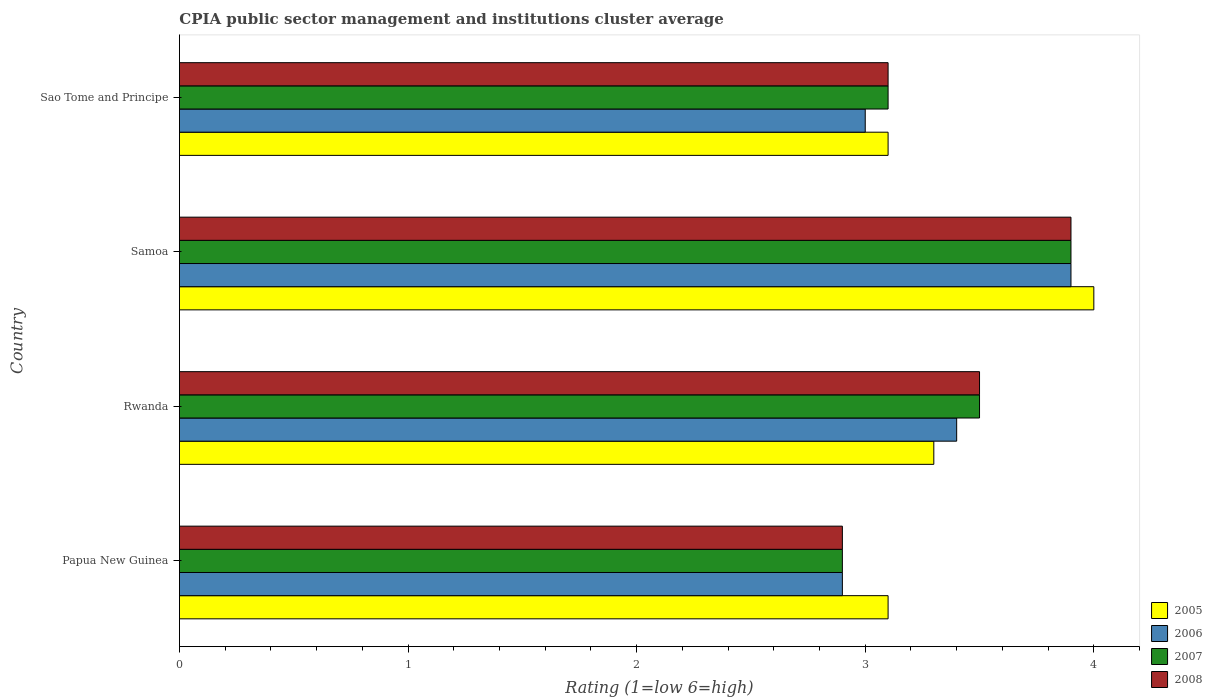How many groups of bars are there?
Your answer should be compact. 4. Are the number of bars per tick equal to the number of legend labels?
Make the answer very short. Yes. How many bars are there on the 2nd tick from the top?
Make the answer very short. 4. How many bars are there on the 1st tick from the bottom?
Offer a very short reply. 4. What is the label of the 3rd group of bars from the top?
Your answer should be very brief. Rwanda. In which country was the CPIA rating in 2006 maximum?
Offer a very short reply. Samoa. In which country was the CPIA rating in 2005 minimum?
Your answer should be very brief. Papua New Guinea. What is the difference between the CPIA rating in 2007 in Papua New Guinea and the CPIA rating in 2005 in Samoa?
Your answer should be compact. -1.1. What is the average CPIA rating in 2005 per country?
Provide a short and direct response. 3.38. What is the difference between the CPIA rating in 2005 and CPIA rating in 2007 in Papua New Guinea?
Provide a short and direct response. 0.2. In how many countries, is the CPIA rating in 2008 greater than 0.4 ?
Provide a succinct answer. 4. What is the ratio of the CPIA rating in 2007 in Samoa to that in Sao Tome and Principe?
Give a very brief answer. 1.26. Is the CPIA rating in 2005 in Rwanda less than that in Samoa?
Give a very brief answer. Yes. What is the difference between the highest and the second highest CPIA rating in 2008?
Give a very brief answer. 0.4. What is the difference between the highest and the lowest CPIA rating in 2007?
Make the answer very short. 1. In how many countries, is the CPIA rating in 2008 greater than the average CPIA rating in 2008 taken over all countries?
Offer a terse response. 2. Is the sum of the CPIA rating in 2007 in Rwanda and Samoa greater than the maximum CPIA rating in 2008 across all countries?
Ensure brevity in your answer.  Yes. What does the 1st bar from the top in Samoa represents?
Your answer should be compact. 2008. What does the 2nd bar from the bottom in Papua New Guinea represents?
Keep it short and to the point. 2006. Is it the case that in every country, the sum of the CPIA rating in 2005 and CPIA rating in 2006 is greater than the CPIA rating in 2008?
Your response must be concise. Yes. What is the difference between two consecutive major ticks on the X-axis?
Your response must be concise. 1. Are the values on the major ticks of X-axis written in scientific E-notation?
Your answer should be very brief. No. Where does the legend appear in the graph?
Make the answer very short. Bottom right. How many legend labels are there?
Keep it short and to the point. 4. What is the title of the graph?
Ensure brevity in your answer.  CPIA public sector management and institutions cluster average. Does "1960" appear as one of the legend labels in the graph?
Make the answer very short. No. What is the label or title of the Y-axis?
Keep it short and to the point. Country. What is the Rating (1=low 6=high) in 2005 in Papua New Guinea?
Ensure brevity in your answer.  3.1. What is the Rating (1=low 6=high) in 2007 in Papua New Guinea?
Give a very brief answer. 2.9. What is the Rating (1=low 6=high) in 2008 in Papua New Guinea?
Your response must be concise. 2.9. What is the Rating (1=low 6=high) of 2007 in Rwanda?
Make the answer very short. 3.5. What is the Rating (1=low 6=high) of 2008 in Samoa?
Ensure brevity in your answer.  3.9. What is the Rating (1=low 6=high) in 2005 in Sao Tome and Principe?
Offer a very short reply. 3.1. What is the Rating (1=low 6=high) in 2006 in Sao Tome and Principe?
Provide a short and direct response. 3. What is the Rating (1=low 6=high) of 2007 in Sao Tome and Principe?
Make the answer very short. 3.1. What is the Rating (1=low 6=high) in 2008 in Sao Tome and Principe?
Ensure brevity in your answer.  3.1. Across all countries, what is the maximum Rating (1=low 6=high) of 2005?
Provide a succinct answer. 4. Across all countries, what is the minimum Rating (1=low 6=high) of 2007?
Ensure brevity in your answer.  2.9. What is the total Rating (1=low 6=high) in 2007 in the graph?
Your answer should be very brief. 13.4. What is the total Rating (1=low 6=high) of 2008 in the graph?
Your answer should be compact. 13.4. What is the difference between the Rating (1=low 6=high) in 2006 in Papua New Guinea and that in Rwanda?
Provide a succinct answer. -0.5. What is the difference between the Rating (1=low 6=high) of 2008 in Papua New Guinea and that in Rwanda?
Provide a succinct answer. -0.6. What is the difference between the Rating (1=low 6=high) of 2006 in Papua New Guinea and that in Samoa?
Offer a terse response. -1. What is the difference between the Rating (1=low 6=high) of 2008 in Papua New Guinea and that in Samoa?
Make the answer very short. -1. What is the difference between the Rating (1=low 6=high) in 2007 in Papua New Guinea and that in Sao Tome and Principe?
Keep it short and to the point. -0.2. What is the difference between the Rating (1=low 6=high) of 2005 in Rwanda and that in Samoa?
Ensure brevity in your answer.  -0.7. What is the difference between the Rating (1=low 6=high) of 2005 in Rwanda and that in Sao Tome and Principe?
Provide a short and direct response. 0.2. What is the difference between the Rating (1=low 6=high) of 2006 in Rwanda and that in Sao Tome and Principe?
Keep it short and to the point. 0.4. What is the difference between the Rating (1=low 6=high) in 2007 in Rwanda and that in Sao Tome and Principe?
Keep it short and to the point. 0.4. What is the difference between the Rating (1=low 6=high) of 2005 in Samoa and that in Sao Tome and Principe?
Provide a succinct answer. 0.9. What is the difference between the Rating (1=low 6=high) of 2006 in Samoa and that in Sao Tome and Principe?
Make the answer very short. 0.9. What is the difference between the Rating (1=low 6=high) of 2007 in Samoa and that in Sao Tome and Principe?
Your answer should be very brief. 0.8. What is the difference between the Rating (1=low 6=high) in 2008 in Samoa and that in Sao Tome and Principe?
Ensure brevity in your answer.  0.8. What is the difference between the Rating (1=low 6=high) in 2005 in Papua New Guinea and the Rating (1=low 6=high) in 2007 in Rwanda?
Your response must be concise. -0.4. What is the difference between the Rating (1=low 6=high) of 2005 in Papua New Guinea and the Rating (1=low 6=high) of 2008 in Rwanda?
Provide a succinct answer. -0.4. What is the difference between the Rating (1=low 6=high) in 2005 in Papua New Guinea and the Rating (1=low 6=high) in 2006 in Samoa?
Offer a very short reply. -0.8. What is the difference between the Rating (1=low 6=high) in 2005 in Papua New Guinea and the Rating (1=low 6=high) in 2007 in Samoa?
Ensure brevity in your answer.  -0.8. What is the difference between the Rating (1=low 6=high) in 2005 in Papua New Guinea and the Rating (1=low 6=high) in 2008 in Samoa?
Make the answer very short. -0.8. What is the difference between the Rating (1=low 6=high) of 2006 in Papua New Guinea and the Rating (1=low 6=high) of 2007 in Samoa?
Your answer should be compact. -1. What is the difference between the Rating (1=low 6=high) of 2007 in Papua New Guinea and the Rating (1=low 6=high) of 2008 in Samoa?
Provide a succinct answer. -1. What is the difference between the Rating (1=low 6=high) in 2005 in Papua New Guinea and the Rating (1=low 6=high) in 2007 in Sao Tome and Principe?
Offer a very short reply. 0. What is the difference between the Rating (1=low 6=high) of 2006 in Papua New Guinea and the Rating (1=low 6=high) of 2007 in Sao Tome and Principe?
Offer a very short reply. -0.2. What is the difference between the Rating (1=low 6=high) of 2006 in Papua New Guinea and the Rating (1=low 6=high) of 2008 in Sao Tome and Principe?
Provide a short and direct response. -0.2. What is the difference between the Rating (1=low 6=high) of 2005 in Rwanda and the Rating (1=low 6=high) of 2006 in Samoa?
Ensure brevity in your answer.  -0.6. What is the difference between the Rating (1=low 6=high) of 2005 in Rwanda and the Rating (1=low 6=high) of 2007 in Samoa?
Offer a terse response. -0.6. What is the difference between the Rating (1=low 6=high) in 2006 in Rwanda and the Rating (1=low 6=high) in 2007 in Samoa?
Ensure brevity in your answer.  -0.5. What is the difference between the Rating (1=low 6=high) of 2007 in Rwanda and the Rating (1=low 6=high) of 2008 in Samoa?
Your answer should be very brief. -0.4. What is the difference between the Rating (1=low 6=high) of 2005 in Rwanda and the Rating (1=low 6=high) of 2008 in Sao Tome and Principe?
Your answer should be very brief. 0.2. What is the difference between the Rating (1=low 6=high) of 2006 in Rwanda and the Rating (1=low 6=high) of 2007 in Sao Tome and Principe?
Your answer should be compact. 0.3. What is the difference between the Rating (1=low 6=high) of 2006 in Rwanda and the Rating (1=low 6=high) of 2008 in Sao Tome and Principe?
Your answer should be compact. 0.3. What is the difference between the Rating (1=low 6=high) of 2005 in Samoa and the Rating (1=low 6=high) of 2006 in Sao Tome and Principe?
Your answer should be very brief. 1. What is the difference between the Rating (1=low 6=high) in 2005 in Samoa and the Rating (1=low 6=high) in 2008 in Sao Tome and Principe?
Give a very brief answer. 0.9. What is the average Rating (1=low 6=high) in 2005 per country?
Provide a succinct answer. 3.38. What is the average Rating (1=low 6=high) in 2006 per country?
Your answer should be compact. 3.3. What is the average Rating (1=low 6=high) of 2007 per country?
Make the answer very short. 3.35. What is the average Rating (1=low 6=high) of 2008 per country?
Provide a short and direct response. 3.35. What is the difference between the Rating (1=low 6=high) of 2005 and Rating (1=low 6=high) of 2006 in Papua New Guinea?
Offer a terse response. 0.2. What is the difference between the Rating (1=low 6=high) of 2005 and Rating (1=low 6=high) of 2007 in Papua New Guinea?
Offer a very short reply. 0.2. What is the difference between the Rating (1=low 6=high) of 2005 and Rating (1=low 6=high) of 2008 in Papua New Guinea?
Offer a terse response. 0.2. What is the difference between the Rating (1=low 6=high) in 2006 and Rating (1=low 6=high) in 2007 in Papua New Guinea?
Keep it short and to the point. 0. What is the difference between the Rating (1=low 6=high) in 2007 and Rating (1=low 6=high) in 2008 in Papua New Guinea?
Offer a terse response. 0. What is the difference between the Rating (1=low 6=high) in 2005 and Rating (1=low 6=high) in 2006 in Rwanda?
Your answer should be compact. -0.1. What is the difference between the Rating (1=low 6=high) in 2006 and Rating (1=low 6=high) in 2007 in Rwanda?
Offer a terse response. -0.1. What is the difference between the Rating (1=low 6=high) of 2006 and Rating (1=low 6=high) of 2008 in Rwanda?
Provide a succinct answer. -0.1. What is the difference between the Rating (1=low 6=high) of 2005 and Rating (1=low 6=high) of 2006 in Samoa?
Your answer should be compact. 0.1. What is the difference between the Rating (1=low 6=high) in 2006 and Rating (1=low 6=high) in 2007 in Samoa?
Give a very brief answer. 0. What is the difference between the Rating (1=low 6=high) in 2007 and Rating (1=low 6=high) in 2008 in Samoa?
Offer a terse response. 0. What is the difference between the Rating (1=low 6=high) of 2005 and Rating (1=low 6=high) of 2006 in Sao Tome and Principe?
Your answer should be very brief. 0.1. What is the difference between the Rating (1=low 6=high) of 2005 and Rating (1=low 6=high) of 2007 in Sao Tome and Principe?
Keep it short and to the point. 0. What is the difference between the Rating (1=low 6=high) in 2005 and Rating (1=low 6=high) in 2008 in Sao Tome and Principe?
Make the answer very short. 0. What is the difference between the Rating (1=low 6=high) in 2006 and Rating (1=low 6=high) in 2007 in Sao Tome and Principe?
Provide a short and direct response. -0.1. What is the ratio of the Rating (1=low 6=high) of 2005 in Papua New Guinea to that in Rwanda?
Your answer should be compact. 0.94. What is the ratio of the Rating (1=low 6=high) in 2006 in Papua New Guinea to that in Rwanda?
Provide a short and direct response. 0.85. What is the ratio of the Rating (1=low 6=high) in 2007 in Papua New Guinea to that in Rwanda?
Offer a very short reply. 0.83. What is the ratio of the Rating (1=low 6=high) of 2008 in Papua New Guinea to that in Rwanda?
Your answer should be compact. 0.83. What is the ratio of the Rating (1=low 6=high) of 2005 in Papua New Guinea to that in Samoa?
Your answer should be compact. 0.78. What is the ratio of the Rating (1=low 6=high) in 2006 in Papua New Guinea to that in Samoa?
Your answer should be very brief. 0.74. What is the ratio of the Rating (1=low 6=high) in 2007 in Papua New Guinea to that in Samoa?
Offer a terse response. 0.74. What is the ratio of the Rating (1=low 6=high) of 2008 in Papua New Guinea to that in Samoa?
Provide a succinct answer. 0.74. What is the ratio of the Rating (1=low 6=high) of 2006 in Papua New Guinea to that in Sao Tome and Principe?
Offer a terse response. 0.97. What is the ratio of the Rating (1=low 6=high) of 2007 in Papua New Guinea to that in Sao Tome and Principe?
Make the answer very short. 0.94. What is the ratio of the Rating (1=low 6=high) in 2008 in Papua New Guinea to that in Sao Tome and Principe?
Make the answer very short. 0.94. What is the ratio of the Rating (1=low 6=high) in 2005 in Rwanda to that in Samoa?
Provide a succinct answer. 0.82. What is the ratio of the Rating (1=low 6=high) of 2006 in Rwanda to that in Samoa?
Offer a very short reply. 0.87. What is the ratio of the Rating (1=low 6=high) of 2007 in Rwanda to that in Samoa?
Your answer should be compact. 0.9. What is the ratio of the Rating (1=low 6=high) of 2008 in Rwanda to that in Samoa?
Keep it short and to the point. 0.9. What is the ratio of the Rating (1=low 6=high) of 2005 in Rwanda to that in Sao Tome and Principe?
Provide a succinct answer. 1.06. What is the ratio of the Rating (1=low 6=high) of 2006 in Rwanda to that in Sao Tome and Principe?
Provide a succinct answer. 1.13. What is the ratio of the Rating (1=low 6=high) of 2007 in Rwanda to that in Sao Tome and Principe?
Your answer should be very brief. 1.13. What is the ratio of the Rating (1=low 6=high) in 2008 in Rwanda to that in Sao Tome and Principe?
Keep it short and to the point. 1.13. What is the ratio of the Rating (1=low 6=high) of 2005 in Samoa to that in Sao Tome and Principe?
Offer a very short reply. 1.29. What is the ratio of the Rating (1=low 6=high) in 2007 in Samoa to that in Sao Tome and Principe?
Your answer should be compact. 1.26. What is the ratio of the Rating (1=low 6=high) of 2008 in Samoa to that in Sao Tome and Principe?
Offer a very short reply. 1.26. What is the difference between the highest and the second highest Rating (1=low 6=high) in 2006?
Provide a short and direct response. 0.5. What is the difference between the highest and the second highest Rating (1=low 6=high) of 2008?
Offer a terse response. 0.4. What is the difference between the highest and the lowest Rating (1=low 6=high) in 2007?
Keep it short and to the point. 1. 